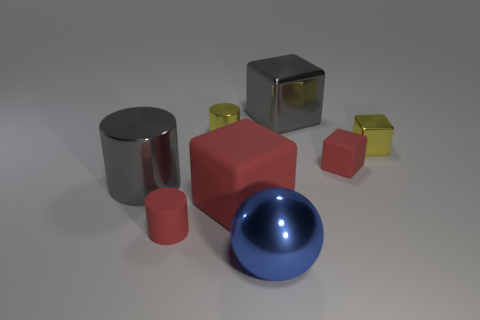There is a cylinder that is the same size as the shiny ball; what color is it?
Make the answer very short. Gray. What is the shape of the gray metal object right of the small red rubber thing that is to the left of the tiny matte cube?
Provide a succinct answer. Cube. There is a red block that is to the left of the blue shiny ball; is its size the same as the yellow cylinder?
Provide a short and direct response. No. What number of other things are made of the same material as the big gray cube?
Keep it short and to the point. 4. How many cyan objects are small metal cylinders or tiny matte blocks?
Give a very brief answer. 0. There is a shiny thing that is the same color as the large cylinder; what size is it?
Ensure brevity in your answer.  Large. There is a small red matte cylinder; how many large gray things are on the left side of it?
Ensure brevity in your answer.  1. How big is the gray object behind the thing that is to the left of the tiny cylinder in front of the gray shiny cylinder?
Offer a very short reply. Large. There is a gray shiny object that is left of the red rubber object to the left of the large red object; is there a tiny yellow metal cylinder that is behind it?
Keep it short and to the point. Yes. Is the number of big purple matte cylinders greater than the number of tiny matte things?
Make the answer very short. No. 